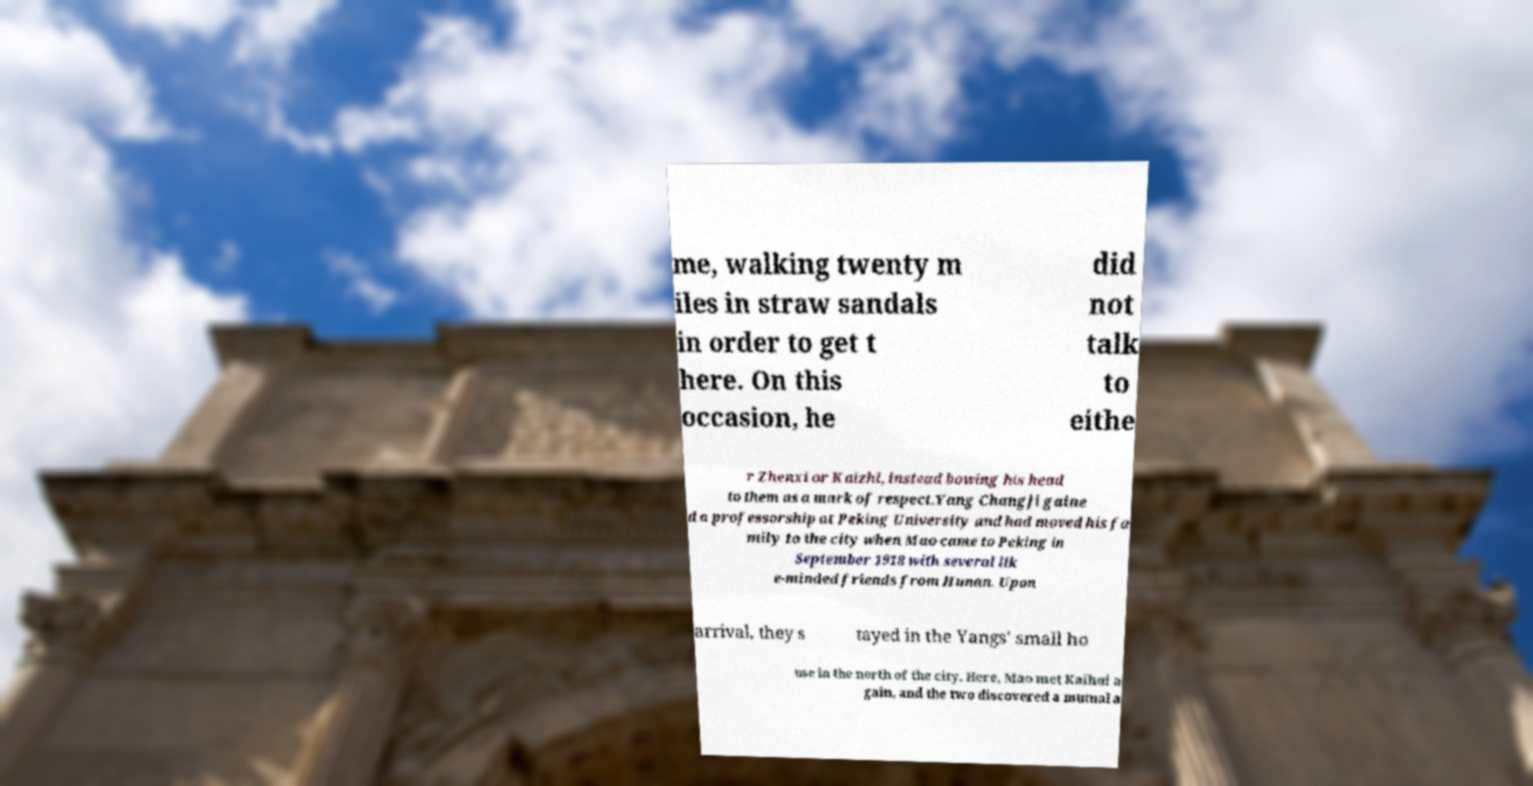Please identify and transcribe the text found in this image. me, walking twenty m iles in straw sandals in order to get t here. On this occasion, he did not talk to eithe r Zhenxi or Kaizhi, instead bowing his head to them as a mark of respect.Yang Changji gaine d a professorship at Peking University and had moved his fa mily to the city when Mao came to Peking in September 1918 with several lik e-minded friends from Hunan. Upon arrival, they s tayed in the Yangs' small ho use in the north of the city. Here, Mao met Kaihui a gain, and the two discovered a mutual a 